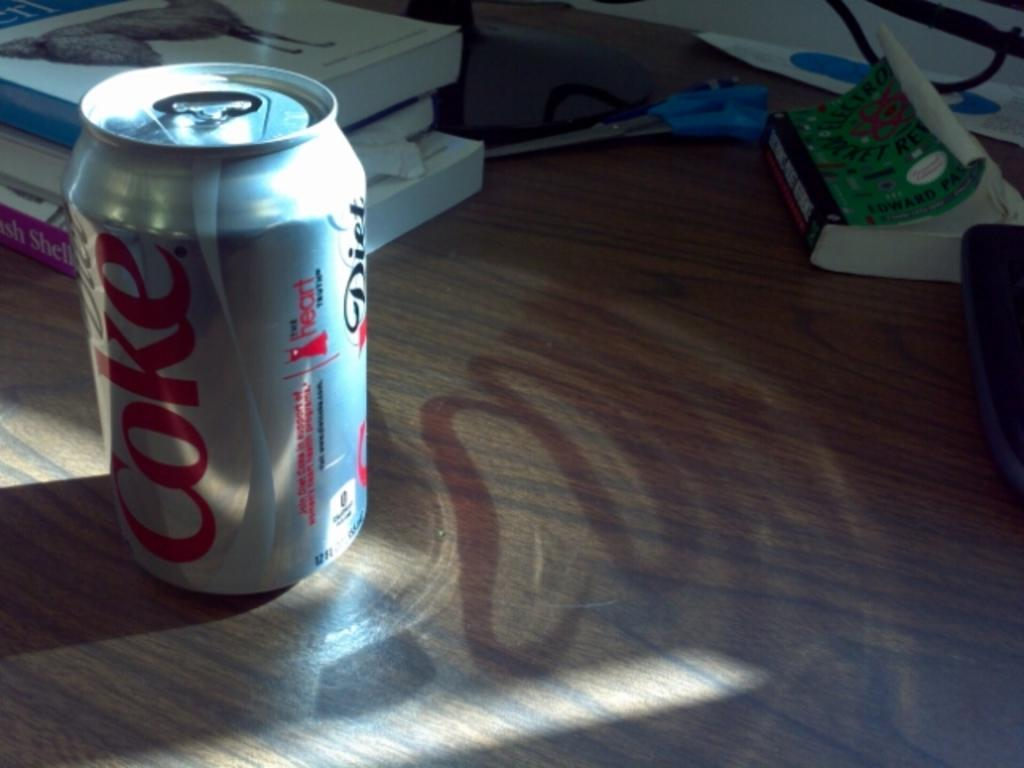<image>
Present a compact description of the photo's key features. A single can of Diet Coke on a table with other items. 